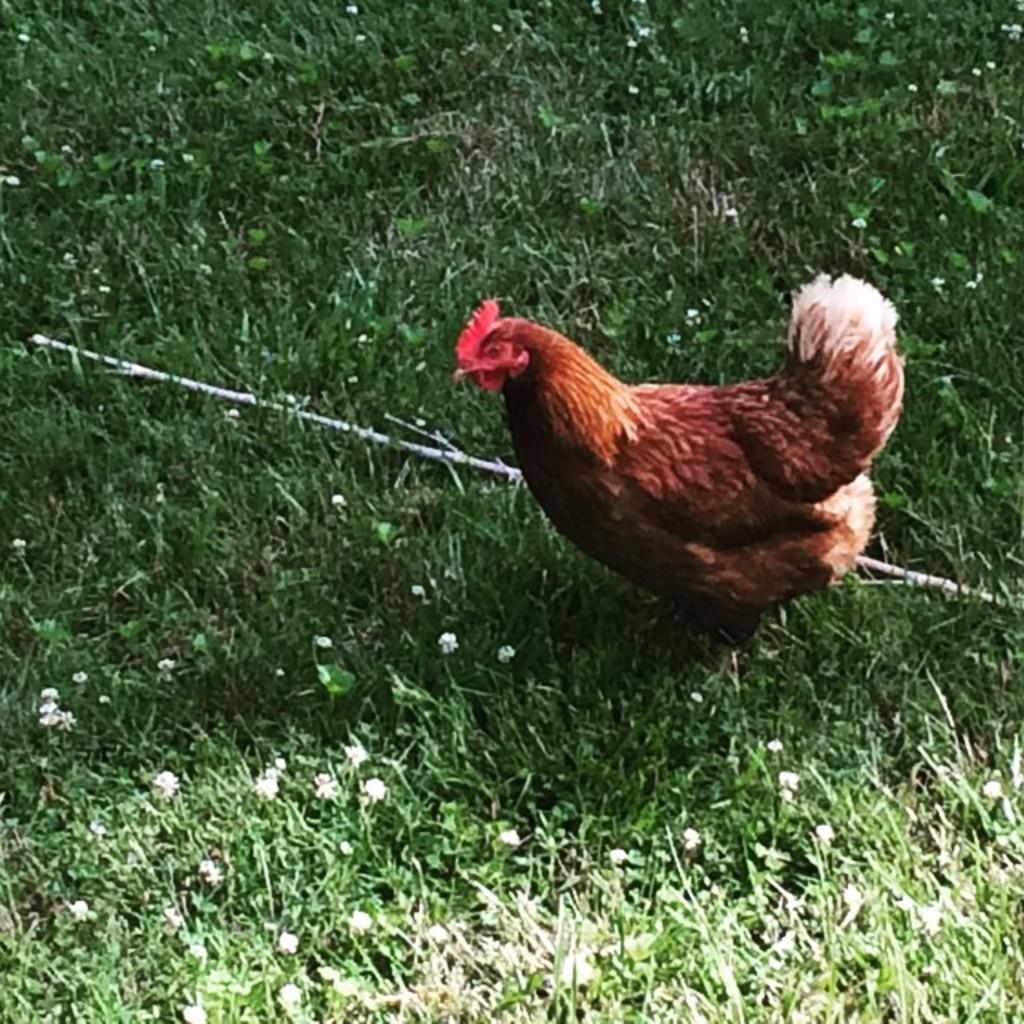What type of area is depicted in the image? There is a garden in the image. What can be found among the plants in the garden? There are tiny white flowers in the garden. What animal is present in the garden? There is a hen standing in the garden. What object can be seen in the image? There is a stick visible in the image. What else is present in the garden besides the flowers and the hen? There are leaves present in the image. What degree does the hen have in the image? The hen does not have a degree in the image, as degrees are not applicable to animals. Is there any indication of a war happening in the garden? There is no indication of a war in the image; it depicts a peaceful garden scene. 